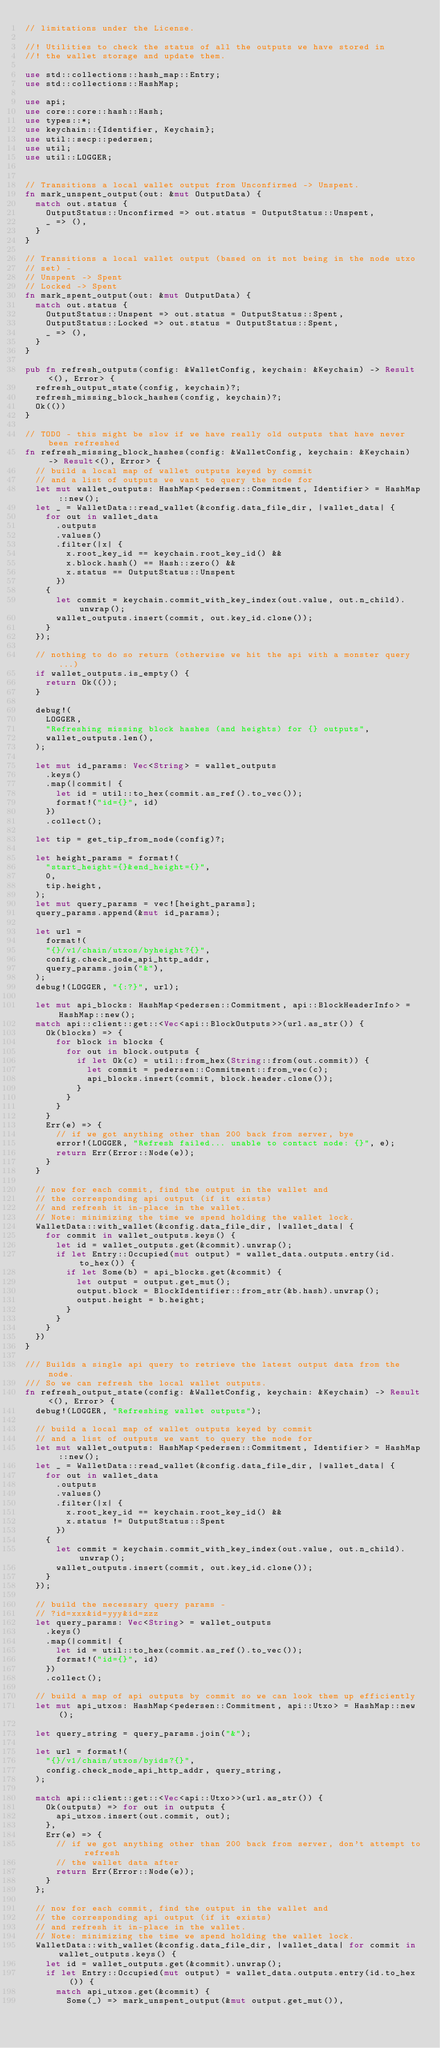Convert code to text. <code><loc_0><loc_0><loc_500><loc_500><_Rust_>// limitations under the License.

//! Utilities to check the status of all the outputs we have stored in
//! the wallet storage and update them.

use std::collections::hash_map::Entry;
use std::collections::HashMap;

use api;
use core::core::hash::Hash;
use types::*;
use keychain::{Identifier, Keychain};
use util::secp::pedersen;
use util;
use util::LOGGER;


// Transitions a local wallet output from Unconfirmed -> Unspent.
fn mark_unspent_output(out: &mut OutputData) {
	match out.status {
		OutputStatus::Unconfirmed => out.status = OutputStatus::Unspent,
		_ => (),
	}
}

// Transitions a local wallet output (based on it not being in the node utxo
// set) -
// Unspent -> Spent
// Locked -> Spent
fn mark_spent_output(out: &mut OutputData) {
	match out.status {
		OutputStatus::Unspent => out.status = OutputStatus::Spent,
		OutputStatus::Locked => out.status = OutputStatus::Spent,
		_ => (),
	}
}

pub fn refresh_outputs(config: &WalletConfig, keychain: &Keychain) -> Result<(), Error> {
	refresh_output_state(config, keychain)?;
	refresh_missing_block_hashes(config, keychain)?;
	Ok(())
}

// TODO - this might be slow if we have really old outputs that have never been refreshed
fn refresh_missing_block_hashes(config: &WalletConfig, keychain: &Keychain) -> Result<(), Error> {
	// build a local map of wallet outputs keyed by commit
	// and a list of outputs we want to query the node for
	let mut wallet_outputs: HashMap<pedersen::Commitment, Identifier> = HashMap::new();
	let _ = WalletData::read_wallet(&config.data_file_dir, |wallet_data| {
		for out in wallet_data
			.outputs
			.values()
			.filter(|x| {
				x.root_key_id == keychain.root_key_id() &&
				x.block.hash() == Hash::zero() &&
				x.status == OutputStatus::Unspent
			})
		{
			let commit = keychain.commit_with_key_index(out.value, out.n_child).unwrap();
			wallet_outputs.insert(commit, out.key_id.clone());
		}
	});

	// nothing to do so return (otherwise we hit the api with a monster query...)
	if wallet_outputs.is_empty() {
		return Ok(());
	}

	debug!(
		LOGGER,
		"Refreshing missing block hashes (and heights) for {} outputs",
		wallet_outputs.len(),
	);

	let mut id_params: Vec<String> = wallet_outputs
		.keys()
		.map(|commit| {
			let id = util::to_hex(commit.as_ref().to_vec());
			format!("id={}", id)
		})
		.collect();

	let tip = get_tip_from_node(config)?;

	let height_params = format!(
		"start_height={}&end_height={}",
		0,
		tip.height,
	);
	let mut query_params = vec![height_params];
	query_params.append(&mut id_params);

	let url =
		format!(
		"{}/v1/chain/utxos/byheight?{}",
		config.check_node_api_http_addr,
		query_params.join("&"),
	);
	debug!(LOGGER, "{:?}", url);

	let mut api_blocks: HashMap<pedersen::Commitment, api::BlockHeaderInfo> = HashMap::new();
	match api::client::get::<Vec<api::BlockOutputs>>(url.as_str()) {
		Ok(blocks) => {
			for block in blocks {
				for out in block.outputs {
					if let Ok(c) = util::from_hex(String::from(out.commit)) {
						let commit = pedersen::Commitment::from_vec(c);
						api_blocks.insert(commit, block.header.clone());
					}
				}
			}
		}
		Err(e) => {
			// if we got anything other than 200 back from server, bye
			error!(LOGGER, "Refresh failed... unable to contact node: {}", e);
			return Err(Error::Node(e));
		}
	}

	// now for each commit, find the output in the wallet and
	// the corresponding api output (if it exists)
	// and refresh it in-place in the wallet.
	// Note: minimizing the time we spend holding the wallet lock.
	WalletData::with_wallet(&config.data_file_dir, |wallet_data| {
		for commit in wallet_outputs.keys() {
			let id = wallet_outputs.get(&commit).unwrap();
			if let Entry::Occupied(mut output) = wallet_data.outputs.entry(id.to_hex()) {
				if let Some(b) = api_blocks.get(&commit) {
					let output = output.get_mut();
					output.block = BlockIdentifier::from_str(&b.hash).unwrap();
					output.height = b.height;
				}
			}
		}
	})
}

/// Builds a single api query to retrieve the latest output data from the node.
/// So we can refresh the local wallet outputs.
fn refresh_output_state(config: &WalletConfig, keychain: &Keychain) -> Result<(), Error> {
	debug!(LOGGER, "Refreshing wallet outputs");

	// build a local map of wallet outputs keyed by commit
	// and a list of outputs we want to query the node for
	let mut wallet_outputs: HashMap<pedersen::Commitment, Identifier> = HashMap::new();
	let _ = WalletData::read_wallet(&config.data_file_dir, |wallet_data| {
		for out in wallet_data
			.outputs
			.values()
			.filter(|x| {
				x.root_key_id == keychain.root_key_id() &&
				x.status != OutputStatus::Spent
			})
		{
			let commit = keychain.commit_with_key_index(out.value, out.n_child).unwrap();
			wallet_outputs.insert(commit, out.key_id.clone());
		}
	});

	// build the necessary query params -
	// ?id=xxx&id=yyy&id=zzz
	let query_params: Vec<String> = wallet_outputs
		.keys()
		.map(|commit| {
			let id = util::to_hex(commit.as_ref().to_vec());
			format!("id={}", id)
		})
		.collect();

	// build a map of api outputs by commit so we can look them up efficiently
	let mut api_utxos: HashMap<pedersen::Commitment, api::Utxo> = HashMap::new();

	let query_string = query_params.join("&");

	let url = format!(
		"{}/v1/chain/utxos/byids?{}",
		config.check_node_api_http_addr, query_string,
	);

	match api::client::get::<Vec<api::Utxo>>(url.as_str()) {
		Ok(outputs) => for out in outputs {
			api_utxos.insert(out.commit, out);
		},
		Err(e) => {
			// if we got anything other than 200 back from server, don't attempt to refresh
			// the wallet data after
			return Err(Error::Node(e));
		}
	};

	// now for each commit, find the output in the wallet and
	// the corresponding api output (if it exists)
	// and refresh it in-place in the wallet.
	// Note: minimizing the time we spend holding the wallet lock.
	WalletData::with_wallet(&config.data_file_dir, |wallet_data| for commit in wallet_outputs.keys() {
		let id = wallet_outputs.get(&commit).unwrap();
		if let Entry::Occupied(mut output) = wallet_data.outputs.entry(id.to_hex()) {
			match api_utxos.get(&commit) {
				Some(_) => mark_unspent_output(&mut output.get_mut()),</code> 